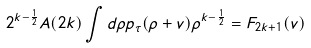<formula> <loc_0><loc_0><loc_500><loc_500>2 ^ { k - \frac { 1 } { 2 } } A ( 2 k ) \int d \rho p _ { \tau } ( \rho + v ) \rho ^ { k - \frac { 1 } { 2 } } = F _ { 2 k + 1 } ( v )</formula> 